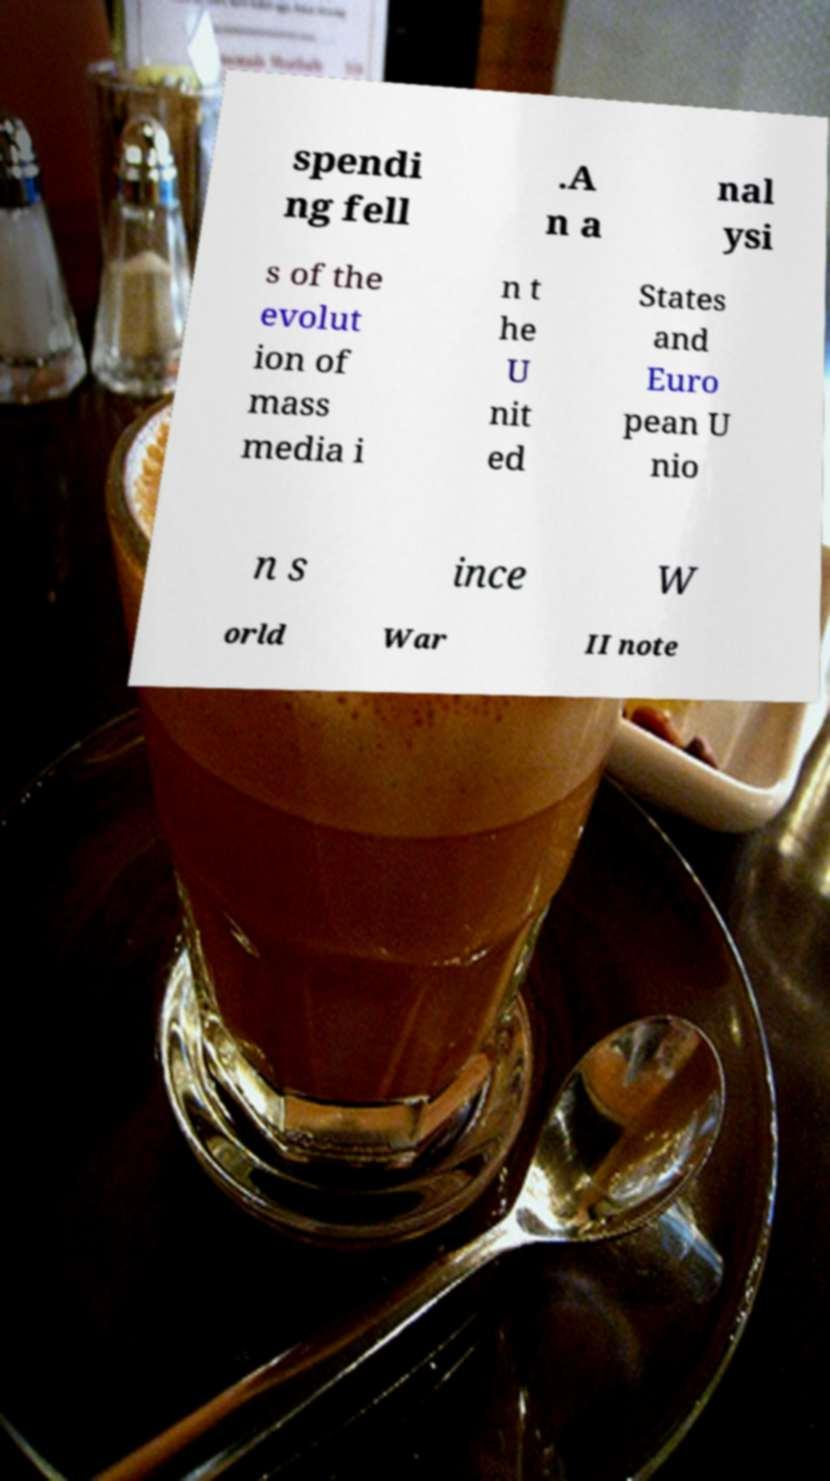Could you assist in decoding the text presented in this image and type it out clearly? spendi ng fell .A n a nal ysi s of the evolut ion of mass media i n t he U nit ed States and Euro pean U nio n s ince W orld War II note 